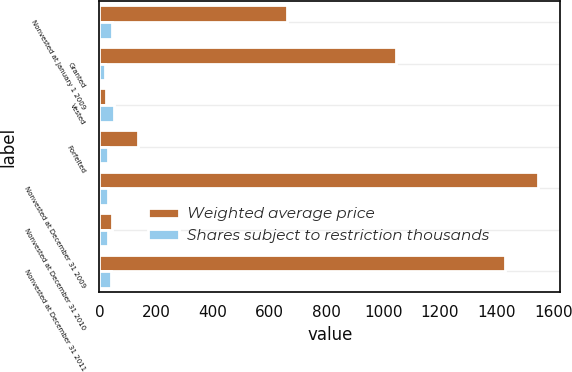<chart> <loc_0><loc_0><loc_500><loc_500><stacked_bar_chart><ecel><fcel>Nonvested at January 1 2009<fcel>Granted<fcel>Vested<fcel>Forfeited<fcel>Nonvested at December 31 2009<fcel>Nonvested at December 31 2010<fcel>Nonvested at December 31 2011<nl><fcel>Weighted average price<fcel>662<fcel>1044<fcel>24<fcel>135<fcel>1547<fcel>45.29<fcel>1430<nl><fcel>Shares subject to restriction thousands<fcel>45.29<fcel>20.61<fcel>51.03<fcel>29.79<fcel>29.9<fcel>30.55<fcel>39.02<nl></chart> 